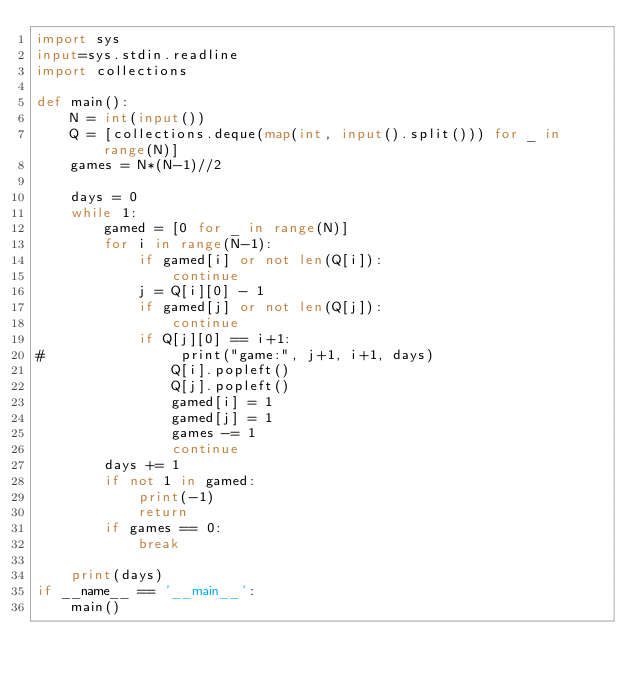<code> <loc_0><loc_0><loc_500><loc_500><_Python_>import sys
input=sys.stdin.readline
import collections

def main():
    N = int(input())
    Q = [collections.deque(map(int, input().split())) for _ in range(N)]
    games = N*(N-1)//2

    days = 0
    while 1:
        gamed = [0 for _ in range(N)]
        for i in range(N-1):
            if gamed[i] or not len(Q[i]):
                continue
            j = Q[i][0] - 1
            if gamed[j] or not len(Q[j]):
                continue
            if Q[j][0] == i+1:
#                print("game:", j+1, i+1, days)
                Q[i].popleft()
                Q[j].popleft()
                gamed[i] = 1
                gamed[j] = 1
                games -= 1
                continue
        days += 1
        if not 1 in gamed:
            print(-1)
            return
        if games == 0:
            break

    print(days)
if __name__ == '__main__':
    main()
</code> 